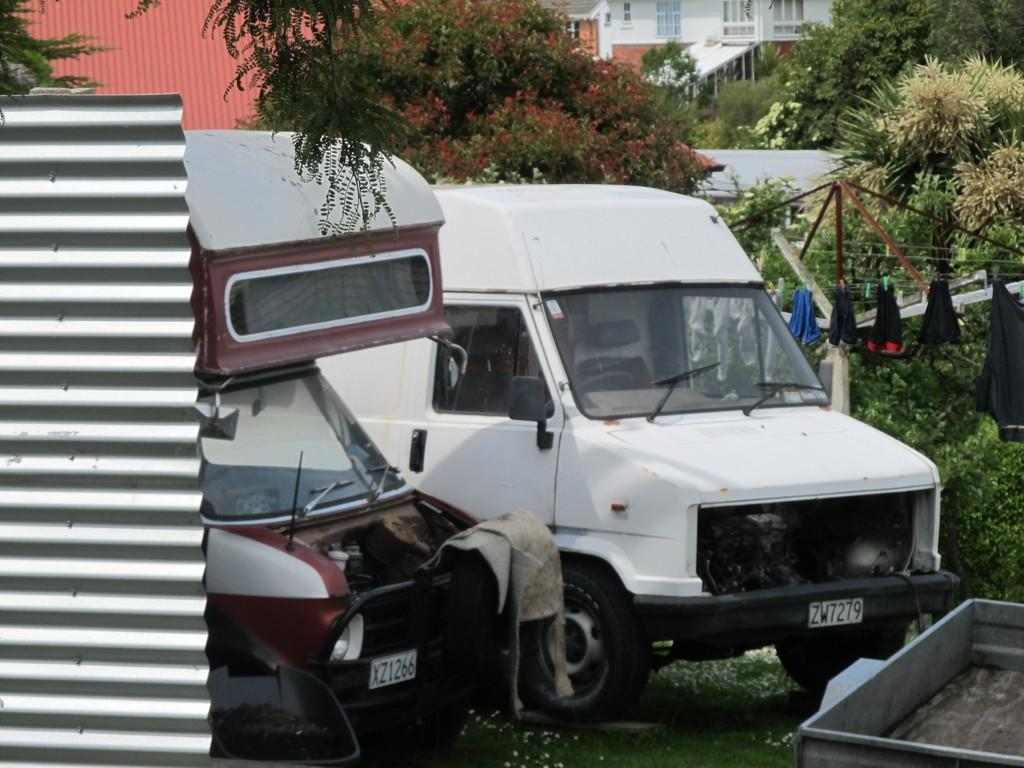What types of objects can be seen in the image? There are vehicles, trees, and houses in the image. What else can be seen hanging in the image? Clothes are hanging on a rope in the image. What type of nail is being used to hang the clothes in the image? There is no nail visible in the image; the clothes are hanging on a rope. What type of insurance policy is being discussed by the people in the image? There are no people present in the image, and therefore no discussion about insurance policies. 